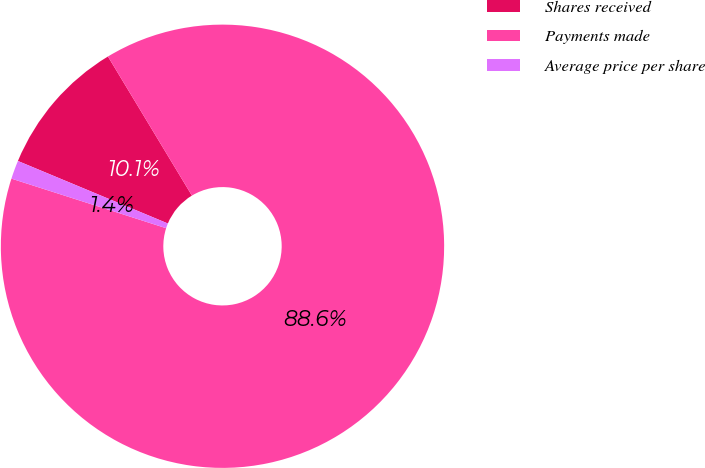Convert chart to OTSL. <chart><loc_0><loc_0><loc_500><loc_500><pie_chart><fcel>Shares received<fcel>Payments made<fcel>Average price per share<nl><fcel>10.07%<fcel>88.58%<fcel>1.35%<nl></chart> 